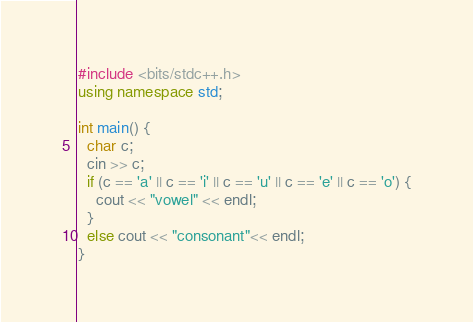Convert code to text. <code><loc_0><loc_0><loc_500><loc_500><_C++_>#include <bits/stdc++.h>
using namespace std;

int main() {
  char c;
  cin >> c;
  if (c == 'a' || c == 'i' || c == 'u' || c == 'e' || c == 'o') {
    cout << "vowel" << endl;
  }
  else cout << "consonant"<< endl;
}</code> 